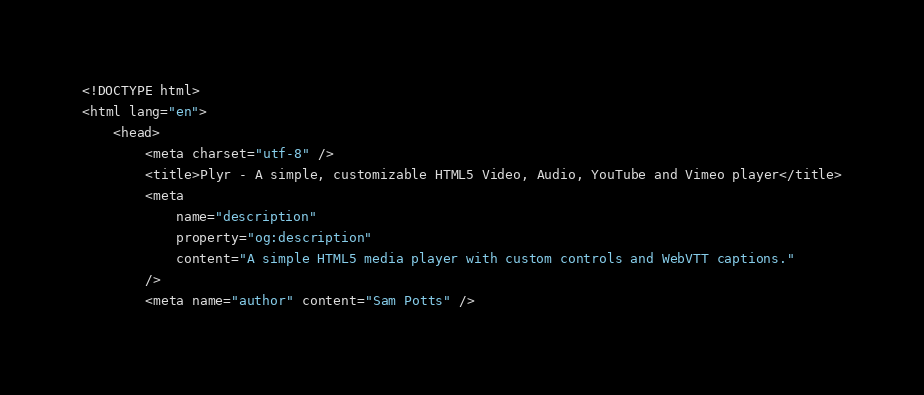<code> <loc_0><loc_0><loc_500><loc_500><_HTML_><!DOCTYPE html>
<html lang="en">
    <head>
        <meta charset="utf-8" />
        <title>Plyr - A simple, customizable HTML5 Video, Audio, YouTube and Vimeo player</title>
        <meta
            name="description"
            property="og:description"
            content="A simple HTML5 media player with custom controls and WebVTT captions."
        />
        <meta name="author" content="Sam Potts" /></code> 